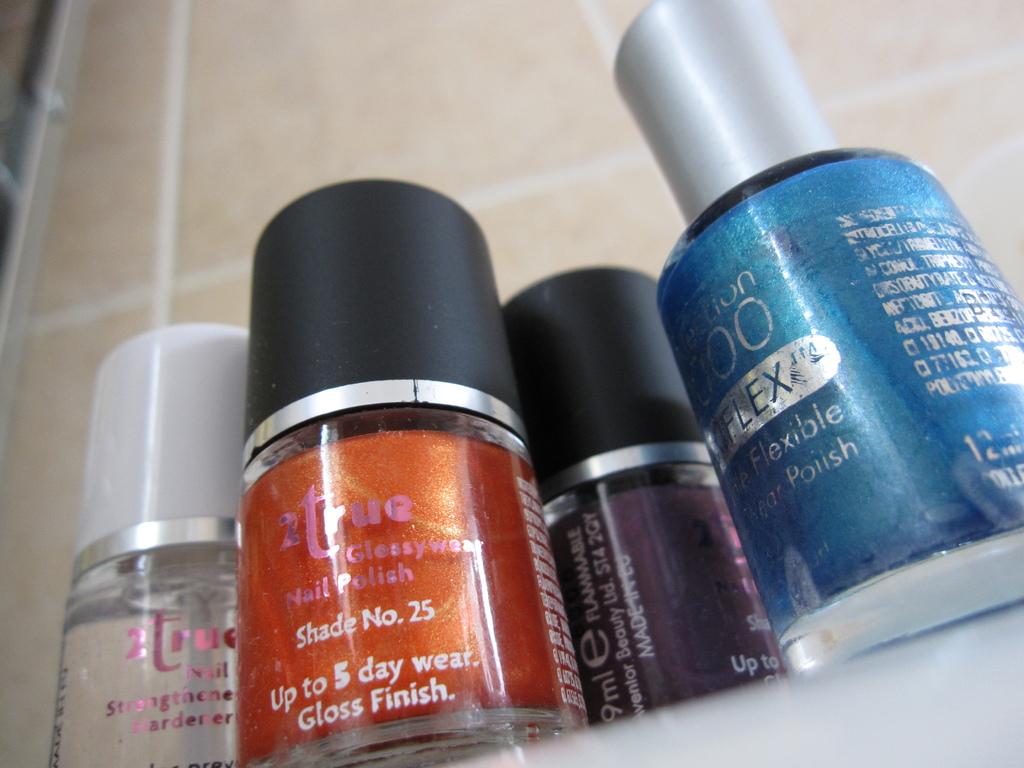What shade no. is the orange polish?
Ensure brevity in your answer.  25. How many different colors of nail polish are there?
Keep it short and to the point. 4. 